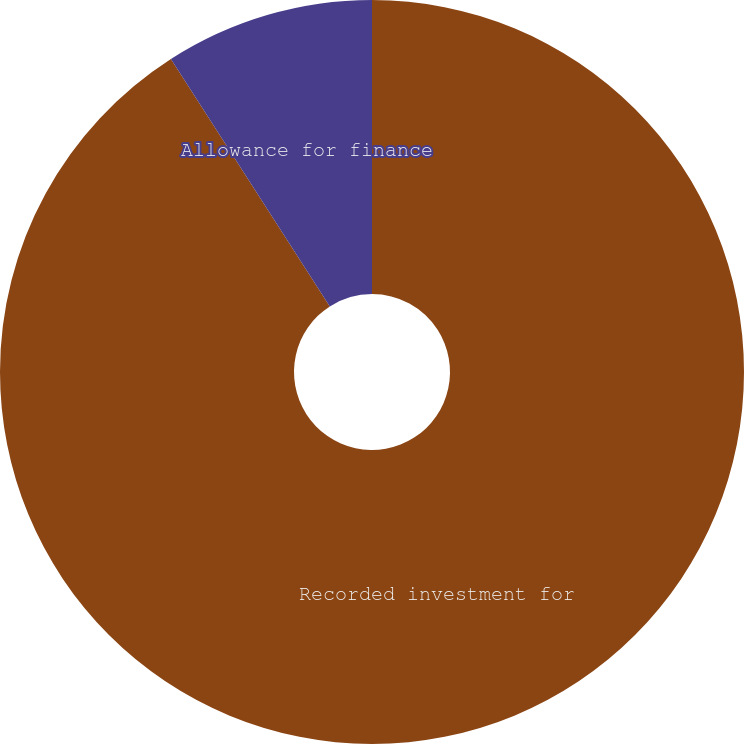Convert chart to OTSL. <chart><loc_0><loc_0><loc_500><loc_500><pie_chart><fcel>Recorded investment for<fcel>Allowance for finance<nl><fcel>90.91%<fcel>9.09%<nl></chart> 